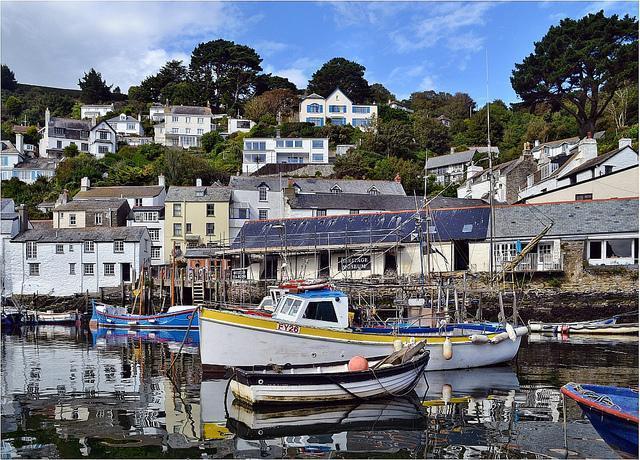How many boats are there?
Give a very brief answer. 4. How many people in the picture are wearing black caps?
Give a very brief answer. 0. 